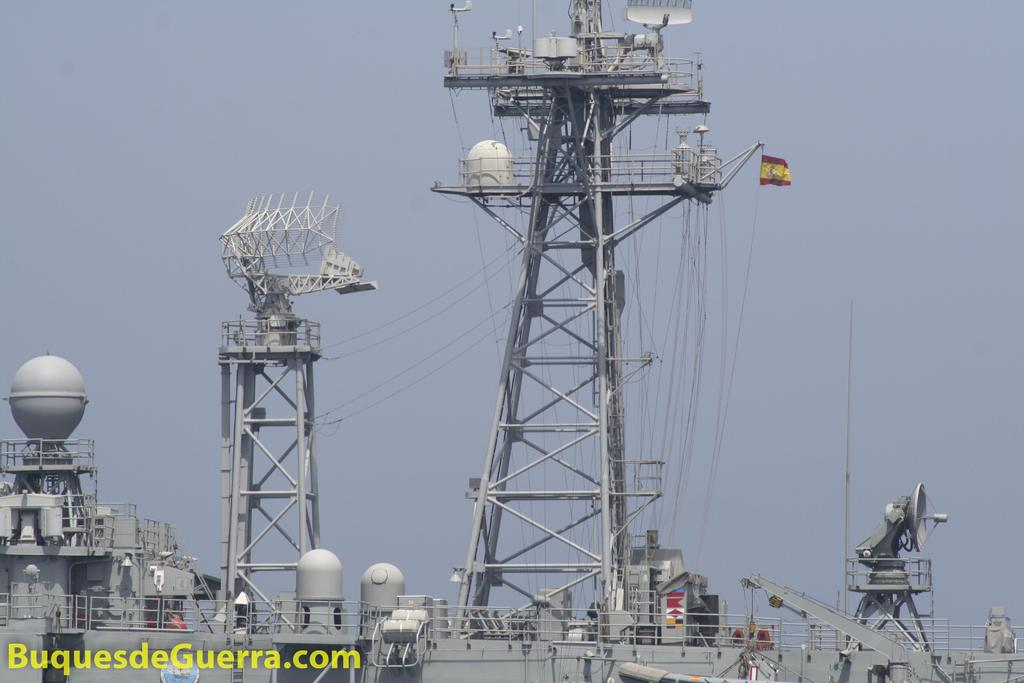What structures are present in the image? There are towers in the image. What else can be seen in the image besides the towers? There are wires and other objects visible in the image. Is there any text present in the image? Yes, there is text at the bottom of the image. What can be seen in the background of the image? The sky is visible in the background of the image. How does the fear blow away in the image? There is no fear present in the image; it is not a subject or object that can be seen or experienced in the image. 